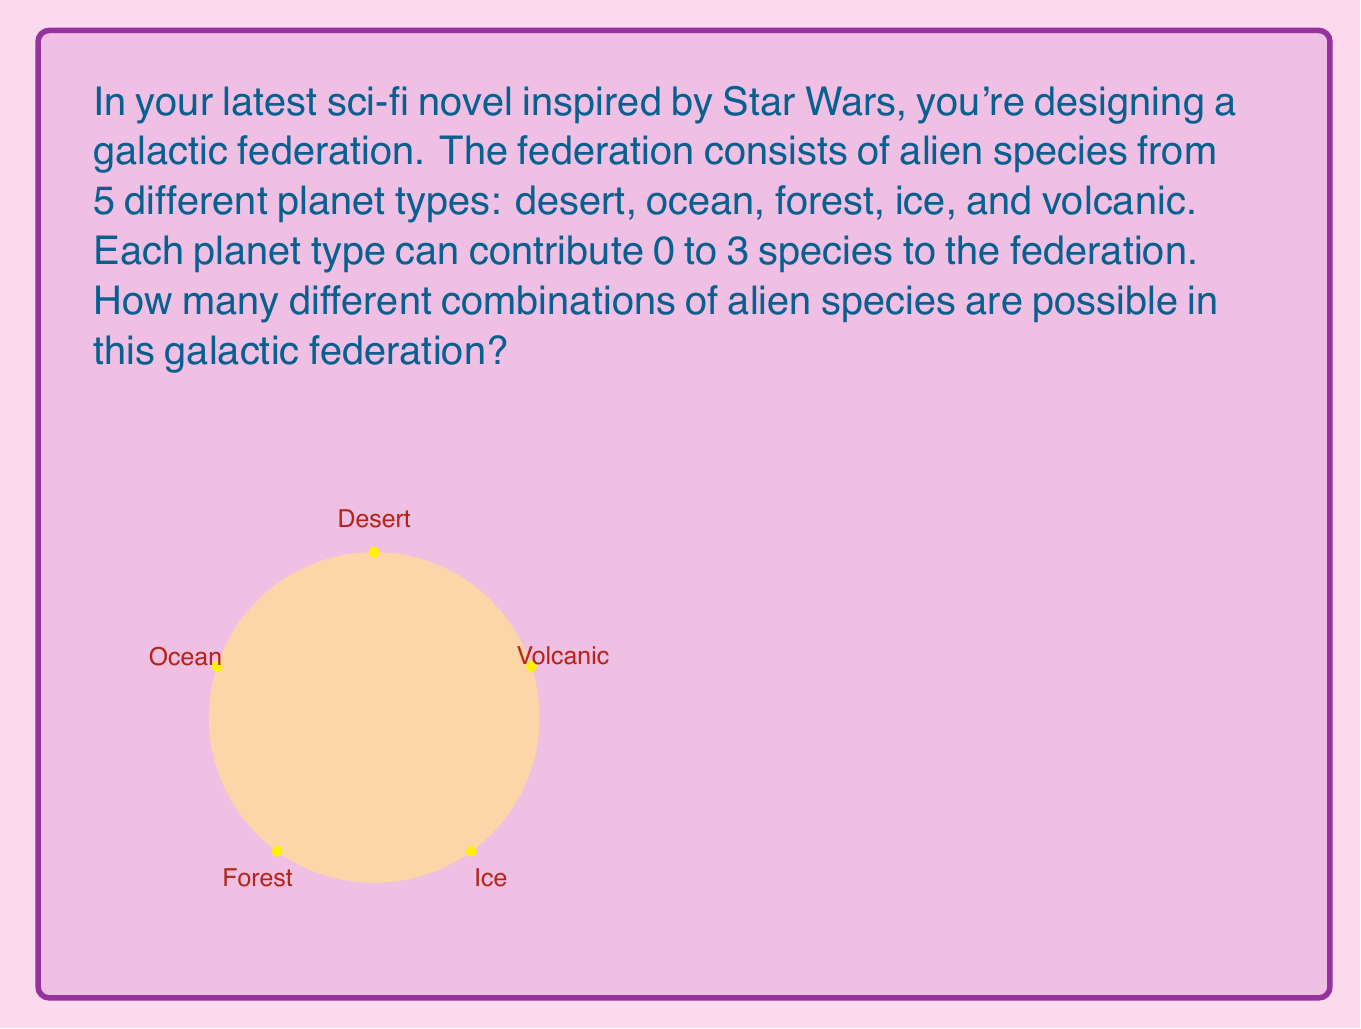Can you answer this question? Let's approach this step-by-step:

1) For each planet type, we have 4 options: 0, 1, 2, or 3 species.

2) We need to choose one of these options for each of the 5 planet types.

3) This scenario is a perfect application of the multiplication principle in combinatorics.

4) The multiplication principle states that if we have $n$ independent events, and each event $i$ has $k_i$ possible outcomes, then the total number of possible outcomes for all events is the product of the number of outcomes for each event:

   $$ \text{Total Outcomes} = k_1 \times k_2 \times ... \times k_n $$

5) In our case, we have 5 independent events (choosing for each planet type), and each event has 4 possible outcomes.

6) Therefore, the total number of possible combinations is:

   $$ 4 \times 4 \times 4 \times 4 \times 4 = 4^5 $$

7) Calculating this:

   $$ 4^5 = 4 \times 4 \times 4 \times 4 \times 4 = 1024 $$

Thus, there are 1024 possible combinations of alien species in this galactic federation.
Answer: $4^5 = 1024$ 